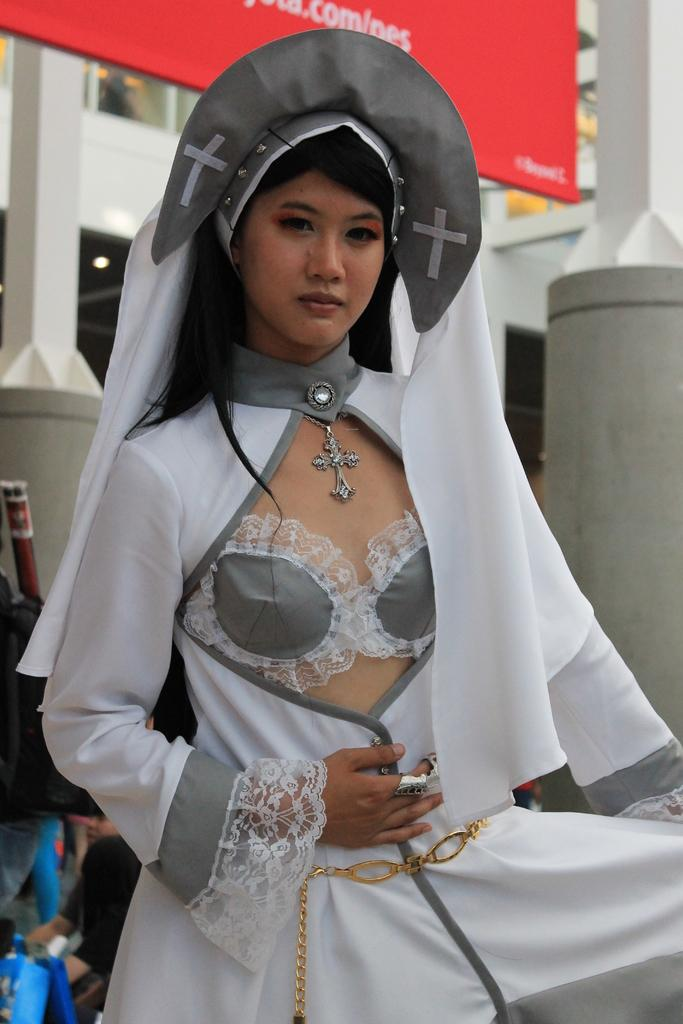What is the main subject of the image? There is a woman standing in the center of the image. Can you describe the woman's attire? The woman is wearing a white costume. What can be seen in the background of the image? There is a building, a banner, pillars, and people in the background of the image. Are there any other objects visible in the background? Yes, there are other objects in the background of the image. What type of jam is being served on the pancake in the image? There is no jam or pancake present in the image. What kind of amusement can be seen in the background of the image? There is no amusement park or ride visible in the image; it features a woman standing in the center and various elements in the background. 